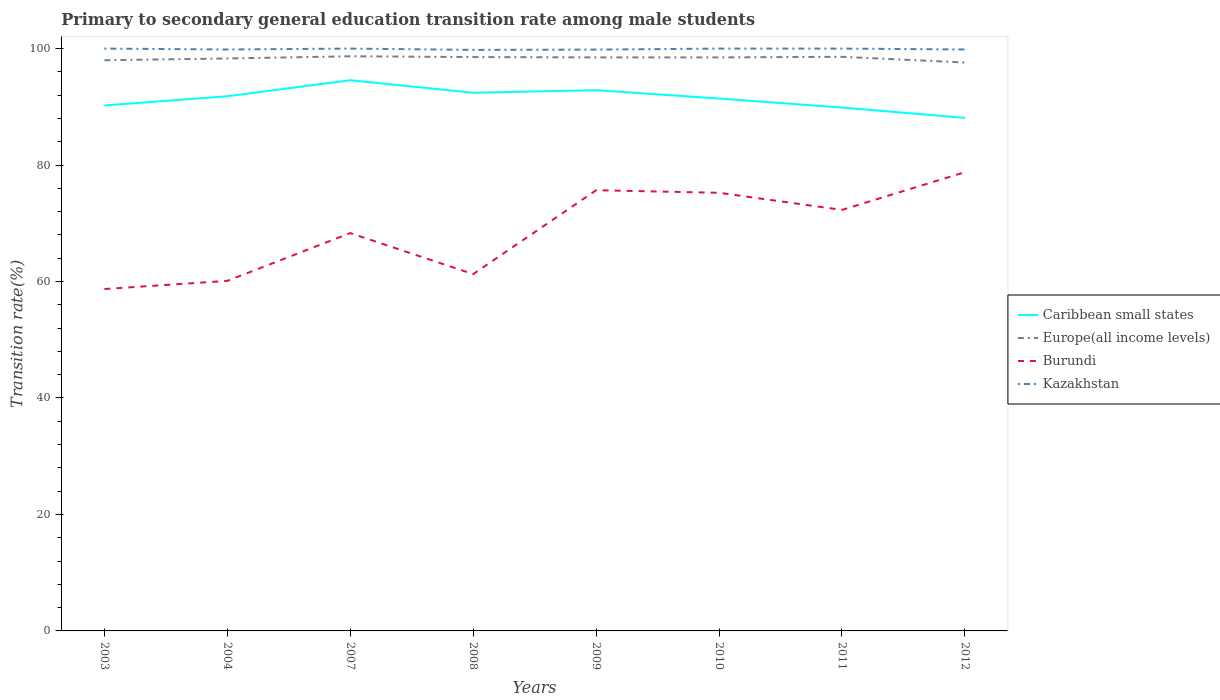Does the line corresponding to Europe(all income levels) intersect with the line corresponding to Burundi?
Your response must be concise. No. Is the number of lines equal to the number of legend labels?
Keep it short and to the point. Yes. Across all years, what is the maximum transition rate in Caribbean small states?
Keep it short and to the point. 88.11. In which year was the transition rate in Europe(all income levels) maximum?
Offer a terse response. 2012. What is the total transition rate in Kazakhstan in the graph?
Give a very brief answer. 0.15. What is the difference between the highest and the second highest transition rate in Caribbean small states?
Your answer should be very brief. 6.46. What is the difference between the highest and the lowest transition rate in Kazakhstan?
Your answer should be very brief. 4. How many years are there in the graph?
Offer a very short reply. 8. How many legend labels are there?
Offer a very short reply. 4. How are the legend labels stacked?
Your response must be concise. Vertical. What is the title of the graph?
Keep it short and to the point. Primary to secondary general education transition rate among male students. Does "Ethiopia" appear as one of the legend labels in the graph?
Give a very brief answer. No. What is the label or title of the X-axis?
Ensure brevity in your answer.  Years. What is the label or title of the Y-axis?
Offer a terse response. Transition rate(%). What is the Transition rate(%) in Caribbean small states in 2003?
Make the answer very short. 90.24. What is the Transition rate(%) in Europe(all income levels) in 2003?
Provide a succinct answer. 98. What is the Transition rate(%) of Burundi in 2003?
Give a very brief answer. 58.71. What is the Transition rate(%) of Caribbean small states in 2004?
Make the answer very short. 91.81. What is the Transition rate(%) in Europe(all income levels) in 2004?
Your response must be concise. 98.3. What is the Transition rate(%) in Burundi in 2004?
Ensure brevity in your answer.  60.12. What is the Transition rate(%) in Kazakhstan in 2004?
Offer a terse response. 99.84. What is the Transition rate(%) in Caribbean small states in 2007?
Give a very brief answer. 94.57. What is the Transition rate(%) of Europe(all income levels) in 2007?
Your answer should be very brief. 98.68. What is the Transition rate(%) in Burundi in 2007?
Make the answer very short. 68.32. What is the Transition rate(%) of Kazakhstan in 2007?
Give a very brief answer. 100. What is the Transition rate(%) of Caribbean small states in 2008?
Your response must be concise. 92.42. What is the Transition rate(%) of Europe(all income levels) in 2008?
Ensure brevity in your answer.  98.54. What is the Transition rate(%) in Burundi in 2008?
Your answer should be compact. 61.27. What is the Transition rate(%) of Kazakhstan in 2008?
Your answer should be very brief. 99.78. What is the Transition rate(%) in Caribbean small states in 2009?
Make the answer very short. 92.86. What is the Transition rate(%) of Europe(all income levels) in 2009?
Give a very brief answer. 98.49. What is the Transition rate(%) in Burundi in 2009?
Your response must be concise. 75.68. What is the Transition rate(%) of Kazakhstan in 2009?
Offer a very short reply. 99.83. What is the Transition rate(%) in Caribbean small states in 2010?
Your response must be concise. 91.42. What is the Transition rate(%) in Europe(all income levels) in 2010?
Give a very brief answer. 98.49. What is the Transition rate(%) in Burundi in 2010?
Your answer should be very brief. 75.24. What is the Transition rate(%) of Caribbean small states in 2011?
Ensure brevity in your answer.  89.88. What is the Transition rate(%) in Europe(all income levels) in 2011?
Your answer should be compact. 98.59. What is the Transition rate(%) in Burundi in 2011?
Your response must be concise. 72.3. What is the Transition rate(%) in Caribbean small states in 2012?
Offer a very short reply. 88.11. What is the Transition rate(%) of Europe(all income levels) in 2012?
Keep it short and to the point. 97.61. What is the Transition rate(%) in Burundi in 2012?
Provide a succinct answer. 78.78. What is the Transition rate(%) in Kazakhstan in 2012?
Offer a very short reply. 99.85. Across all years, what is the maximum Transition rate(%) of Caribbean small states?
Ensure brevity in your answer.  94.57. Across all years, what is the maximum Transition rate(%) of Europe(all income levels)?
Offer a very short reply. 98.68. Across all years, what is the maximum Transition rate(%) of Burundi?
Offer a very short reply. 78.78. Across all years, what is the maximum Transition rate(%) in Kazakhstan?
Provide a succinct answer. 100. Across all years, what is the minimum Transition rate(%) in Caribbean small states?
Ensure brevity in your answer.  88.11. Across all years, what is the minimum Transition rate(%) in Europe(all income levels)?
Your answer should be compact. 97.61. Across all years, what is the minimum Transition rate(%) of Burundi?
Your answer should be very brief. 58.71. Across all years, what is the minimum Transition rate(%) in Kazakhstan?
Offer a terse response. 99.78. What is the total Transition rate(%) of Caribbean small states in the graph?
Your response must be concise. 731.31. What is the total Transition rate(%) in Europe(all income levels) in the graph?
Your answer should be very brief. 786.71. What is the total Transition rate(%) of Burundi in the graph?
Your answer should be very brief. 550.42. What is the total Transition rate(%) of Kazakhstan in the graph?
Your answer should be very brief. 799.3. What is the difference between the Transition rate(%) of Caribbean small states in 2003 and that in 2004?
Your answer should be compact. -1.58. What is the difference between the Transition rate(%) of Europe(all income levels) in 2003 and that in 2004?
Ensure brevity in your answer.  -0.3. What is the difference between the Transition rate(%) of Burundi in 2003 and that in 2004?
Provide a short and direct response. -1.41. What is the difference between the Transition rate(%) in Kazakhstan in 2003 and that in 2004?
Ensure brevity in your answer.  0.16. What is the difference between the Transition rate(%) in Caribbean small states in 2003 and that in 2007?
Provide a short and direct response. -4.33. What is the difference between the Transition rate(%) of Europe(all income levels) in 2003 and that in 2007?
Keep it short and to the point. -0.68. What is the difference between the Transition rate(%) of Burundi in 2003 and that in 2007?
Your answer should be very brief. -9.61. What is the difference between the Transition rate(%) of Kazakhstan in 2003 and that in 2007?
Your answer should be very brief. 0. What is the difference between the Transition rate(%) of Caribbean small states in 2003 and that in 2008?
Keep it short and to the point. -2.18. What is the difference between the Transition rate(%) of Europe(all income levels) in 2003 and that in 2008?
Provide a short and direct response. -0.54. What is the difference between the Transition rate(%) of Burundi in 2003 and that in 2008?
Offer a very short reply. -2.56. What is the difference between the Transition rate(%) of Kazakhstan in 2003 and that in 2008?
Your answer should be compact. 0.22. What is the difference between the Transition rate(%) in Caribbean small states in 2003 and that in 2009?
Give a very brief answer. -2.62. What is the difference between the Transition rate(%) in Europe(all income levels) in 2003 and that in 2009?
Make the answer very short. -0.49. What is the difference between the Transition rate(%) of Burundi in 2003 and that in 2009?
Your answer should be compact. -16.97. What is the difference between the Transition rate(%) of Kazakhstan in 2003 and that in 2009?
Give a very brief answer. 0.17. What is the difference between the Transition rate(%) of Caribbean small states in 2003 and that in 2010?
Provide a succinct answer. -1.19. What is the difference between the Transition rate(%) of Europe(all income levels) in 2003 and that in 2010?
Make the answer very short. -0.48. What is the difference between the Transition rate(%) of Burundi in 2003 and that in 2010?
Make the answer very short. -16.52. What is the difference between the Transition rate(%) of Caribbean small states in 2003 and that in 2011?
Provide a short and direct response. 0.36. What is the difference between the Transition rate(%) in Europe(all income levels) in 2003 and that in 2011?
Provide a succinct answer. -0.58. What is the difference between the Transition rate(%) in Burundi in 2003 and that in 2011?
Your answer should be very brief. -13.59. What is the difference between the Transition rate(%) in Caribbean small states in 2003 and that in 2012?
Provide a succinct answer. 2.13. What is the difference between the Transition rate(%) of Europe(all income levels) in 2003 and that in 2012?
Offer a very short reply. 0.39. What is the difference between the Transition rate(%) of Burundi in 2003 and that in 2012?
Keep it short and to the point. -20.07. What is the difference between the Transition rate(%) of Kazakhstan in 2003 and that in 2012?
Provide a succinct answer. 0.15. What is the difference between the Transition rate(%) in Caribbean small states in 2004 and that in 2007?
Offer a terse response. -2.76. What is the difference between the Transition rate(%) of Europe(all income levels) in 2004 and that in 2007?
Your answer should be very brief. -0.38. What is the difference between the Transition rate(%) in Burundi in 2004 and that in 2007?
Keep it short and to the point. -8.2. What is the difference between the Transition rate(%) of Kazakhstan in 2004 and that in 2007?
Provide a succinct answer. -0.16. What is the difference between the Transition rate(%) in Caribbean small states in 2004 and that in 2008?
Give a very brief answer. -0.6. What is the difference between the Transition rate(%) of Europe(all income levels) in 2004 and that in 2008?
Provide a succinct answer. -0.24. What is the difference between the Transition rate(%) in Burundi in 2004 and that in 2008?
Make the answer very short. -1.16. What is the difference between the Transition rate(%) in Kazakhstan in 2004 and that in 2008?
Ensure brevity in your answer.  0.07. What is the difference between the Transition rate(%) in Caribbean small states in 2004 and that in 2009?
Provide a succinct answer. -1.05. What is the difference between the Transition rate(%) of Europe(all income levels) in 2004 and that in 2009?
Ensure brevity in your answer.  -0.19. What is the difference between the Transition rate(%) of Burundi in 2004 and that in 2009?
Provide a short and direct response. -15.57. What is the difference between the Transition rate(%) of Kazakhstan in 2004 and that in 2009?
Provide a short and direct response. 0.02. What is the difference between the Transition rate(%) of Caribbean small states in 2004 and that in 2010?
Your answer should be compact. 0.39. What is the difference between the Transition rate(%) of Europe(all income levels) in 2004 and that in 2010?
Provide a short and direct response. -0.18. What is the difference between the Transition rate(%) in Burundi in 2004 and that in 2010?
Ensure brevity in your answer.  -15.12. What is the difference between the Transition rate(%) of Kazakhstan in 2004 and that in 2010?
Your response must be concise. -0.16. What is the difference between the Transition rate(%) in Caribbean small states in 2004 and that in 2011?
Offer a terse response. 1.94. What is the difference between the Transition rate(%) of Europe(all income levels) in 2004 and that in 2011?
Provide a short and direct response. -0.28. What is the difference between the Transition rate(%) in Burundi in 2004 and that in 2011?
Make the answer very short. -12.18. What is the difference between the Transition rate(%) of Kazakhstan in 2004 and that in 2011?
Provide a succinct answer. -0.16. What is the difference between the Transition rate(%) of Caribbean small states in 2004 and that in 2012?
Keep it short and to the point. 3.7. What is the difference between the Transition rate(%) in Europe(all income levels) in 2004 and that in 2012?
Offer a very short reply. 0.69. What is the difference between the Transition rate(%) in Burundi in 2004 and that in 2012?
Your response must be concise. -18.66. What is the difference between the Transition rate(%) in Kazakhstan in 2004 and that in 2012?
Make the answer very short. -0. What is the difference between the Transition rate(%) in Caribbean small states in 2007 and that in 2008?
Give a very brief answer. 2.15. What is the difference between the Transition rate(%) of Europe(all income levels) in 2007 and that in 2008?
Your answer should be compact. 0.14. What is the difference between the Transition rate(%) in Burundi in 2007 and that in 2008?
Make the answer very short. 7.05. What is the difference between the Transition rate(%) in Kazakhstan in 2007 and that in 2008?
Ensure brevity in your answer.  0.22. What is the difference between the Transition rate(%) in Caribbean small states in 2007 and that in 2009?
Your answer should be very brief. 1.71. What is the difference between the Transition rate(%) in Europe(all income levels) in 2007 and that in 2009?
Ensure brevity in your answer.  0.19. What is the difference between the Transition rate(%) in Burundi in 2007 and that in 2009?
Your answer should be very brief. -7.36. What is the difference between the Transition rate(%) of Kazakhstan in 2007 and that in 2009?
Your answer should be compact. 0.17. What is the difference between the Transition rate(%) of Caribbean small states in 2007 and that in 2010?
Your answer should be very brief. 3.15. What is the difference between the Transition rate(%) in Europe(all income levels) in 2007 and that in 2010?
Provide a short and direct response. 0.19. What is the difference between the Transition rate(%) of Burundi in 2007 and that in 2010?
Your response must be concise. -6.92. What is the difference between the Transition rate(%) in Caribbean small states in 2007 and that in 2011?
Keep it short and to the point. 4.69. What is the difference between the Transition rate(%) in Europe(all income levels) in 2007 and that in 2011?
Ensure brevity in your answer.  0.09. What is the difference between the Transition rate(%) of Burundi in 2007 and that in 2011?
Your answer should be very brief. -3.98. What is the difference between the Transition rate(%) of Caribbean small states in 2007 and that in 2012?
Make the answer very short. 6.46. What is the difference between the Transition rate(%) in Europe(all income levels) in 2007 and that in 2012?
Your response must be concise. 1.07. What is the difference between the Transition rate(%) of Burundi in 2007 and that in 2012?
Your answer should be compact. -10.46. What is the difference between the Transition rate(%) in Kazakhstan in 2007 and that in 2012?
Provide a short and direct response. 0.15. What is the difference between the Transition rate(%) of Caribbean small states in 2008 and that in 2009?
Your answer should be compact. -0.44. What is the difference between the Transition rate(%) in Europe(all income levels) in 2008 and that in 2009?
Offer a terse response. 0.06. What is the difference between the Transition rate(%) in Burundi in 2008 and that in 2009?
Make the answer very short. -14.41. What is the difference between the Transition rate(%) in Kazakhstan in 2008 and that in 2009?
Your answer should be compact. -0.05. What is the difference between the Transition rate(%) in Caribbean small states in 2008 and that in 2010?
Make the answer very short. 0.99. What is the difference between the Transition rate(%) in Europe(all income levels) in 2008 and that in 2010?
Provide a succinct answer. 0.06. What is the difference between the Transition rate(%) of Burundi in 2008 and that in 2010?
Provide a short and direct response. -13.96. What is the difference between the Transition rate(%) in Kazakhstan in 2008 and that in 2010?
Make the answer very short. -0.22. What is the difference between the Transition rate(%) of Caribbean small states in 2008 and that in 2011?
Offer a very short reply. 2.54. What is the difference between the Transition rate(%) in Europe(all income levels) in 2008 and that in 2011?
Provide a succinct answer. -0.04. What is the difference between the Transition rate(%) in Burundi in 2008 and that in 2011?
Your answer should be very brief. -11.03. What is the difference between the Transition rate(%) in Kazakhstan in 2008 and that in 2011?
Provide a succinct answer. -0.22. What is the difference between the Transition rate(%) in Caribbean small states in 2008 and that in 2012?
Offer a terse response. 4.3. What is the difference between the Transition rate(%) in Europe(all income levels) in 2008 and that in 2012?
Offer a terse response. 0.93. What is the difference between the Transition rate(%) in Burundi in 2008 and that in 2012?
Make the answer very short. -17.51. What is the difference between the Transition rate(%) in Kazakhstan in 2008 and that in 2012?
Keep it short and to the point. -0.07. What is the difference between the Transition rate(%) in Caribbean small states in 2009 and that in 2010?
Provide a short and direct response. 1.44. What is the difference between the Transition rate(%) of Europe(all income levels) in 2009 and that in 2010?
Your answer should be compact. 0. What is the difference between the Transition rate(%) of Burundi in 2009 and that in 2010?
Keep it short and to the point. 0.45. What is the difference between the Transition rate(%) in Kazakhstan in 2009 and that in 2010?
Make the answer very short. -0.17. What is the difference between the Transition rate(%) of Caribbean small states in 2009 and that in 2011?
Make the answer very short. 2.98. What is the difference between the Transition rate(%) in Europe(all income levels) in 2009 and that in 2011?
Your answer should be compact. -0.1. What is the difference between the Transition rate(%) in Burundi in 2009 and that in 2011?
Your answer should be very brief. 3.38. What is the difference between the Transition rate(%) of Kazakhstan in 2009 and that in 2011?
Provide a short and direct response. -0.17. What is the difference between the Transition rate(%) of Caribbean small states in 2009 and that in 2012?
Provide a succinct answer. 4.75. What is the difference between the Transition rate(%) in Europe(all income levels) in 2009 and that in 2012?
Ensure brevity in your answer.  0.88. What is the difference between the Transition rate(%) in Burundi in 2009 and that in 2012?
Your response must be concise. -3.1. What is the difference between the Transition rate(%) of Kazakhstan in 2009 and that in 2012?
Your response must be concise. -0.02. What is the difference between the Transition rate(%) of Caribbean small states in 2010 and that in 2011?
Your response must be concise. 1.55. What is the difference between the Transition rate(%) of Europe(all income levels) in 2010 and that in 2011?
Your answer should be very brief. -0.1. What is the difference between the Transition rate(%) in Burundi in 2010 and that in 2011?
Give a very brief answer. 2.94. What is the difference between the Transition rate(%) in Caribbean small states in 2010 and that in 2012?
Your answer should be very brief. 3.31. What is the difference between the Transition rate(%) in Europe(all income levels) in 2010 and that in 2012?
Offer a terse response. 0.88. What is the difference between the Transition rate(%) in Burundi in 2010 and that in 2012?
Ensure brevity in your answer.  -3.54. What is the difference between the Transition rate(%) of Kazakhstan in 2010 and that in 2012?
Make the answer very short. 0.15. What is the difference between the Transition rate(%) in Caribbean small states in 2011 and that in 2012?
Offer a very short reply. 1.77. What is the difference between the Transition rate(%) in Europe(all income levels) in 2011 and that in 2012?
Provide a succinct answer. 0.98. What is the difference between the Transition rate(%) in Burundi in 2011 and that in 2012?
Your answer should be compact. -6.48. What is the difference between the Transition rate(%) of Kazakhstan in 2011 and that in 2012?
Make the answer very short. 0.15. What is the difference between the Transition rate(%) of Caribbean small states in 2003 and the Transition rate(%) of Europe(all income levels) in 2004?
Offer a terse response. -8.07. What is the difference between the Transition rate(%) of Caribbean small states in 2003 and the Transition rate(%) of Burundi in 2004?
Provide a succinct answer. 30.12. What is the difference between the Transition rate(%) in Caribbean small states in 2003 and the Transition rate(%) in Kazakhstan in 2004?
Provide a succinct answer. -9.61. What is the difference between the Transition rate(%) in Europe(all income levels) in 2003 and the Transition rate(%) in Burundi in 2004?
Keep it short and to the point. 37.89. What is the difference between the Transition rate(%) of Europe(all income levels) in 2003 and the Transition rate(%) of Kazakhstan in 2004?
Ensure brevity in your answer.  -1.84. What is the difference between the Transition rate(%) in Burundi in 2003 and the Transition rate(%) in Kazakhstan in 2004?
Provide a short and direct response. -41.13. What is the difference between the Transition rate(%) in Caribbean small states in 2003 and the Transition rate(%) in Europe(all income levels) in 2007?
Give a very brief answer. -8.45. What is the difference between the Transition rate(%) in Caribbean small states in 2003 and the Transition rate(%) in Burundi in 2007?
Provide a short and direct response. 21.92. What is the difference between the Transition rate(%) of Caribbean small states in 2003 and the Transition rate(%) of Kazakhstan in 2007?
Offer a very short reply. -9.76. What is the difference between the Transition rate(%) in Europe(all income levels) in 2003 and the Transition rate(%) in Burundi in 2007?
Your response must be concise. 29.68. What is the difference between the Transition rate(%) in Europe(all income levels) in 2003 and the Transition rate(%) in Kazakhstan in 2007?
Your answer should be compact. -2. What is the difference between the Transition rate(%) of Burundi in 2003 and the Transition rate(%) of Kazakhstan in 2007?
Keep it short and to the point. -41.29. What is the difference between the Transition rate(%) in Caribbean small states in 2003 and the Transition rate(%) in Europe(all income levels) in 2008?
Ensure brevity in your answer.  -8.31. What is the difference between the Transition rate(%) in Caribbean small states in 2003 and the Transition rate(%) in Burundi in 2008?
Provide a succinct answer. 28.96. What is the difference between the Transition rate(%) in Caribbean small states in 2003 and the Transition rate(%) in Kazakhstan in 2008?
Give a very brief answer. -9.54. What is the difference between the Transition rate(%) in Europe(all income levels) in 2003 and the Transition rate(%) in Burundi in 2008?
Your answer should be very brief. 36.73. What is the difference between the Transition rate(%) of Europe(all income levels) in 2003 and the Transition rate(%) of Kazakhstan in 2008?
Your answer should be very brief. -1.78. What is the difference between the Transition rate(%) in Burundi in 2003 and the Transition rate(%) in Kazakhstan in 2008?
Offer a terse response. -41.07. What is the difference between the Transition rate(%) of Caribbean small states in 2003 and the Transition rate(%) of Europe(all income levels) in 2009?
Offer a very short reply. -8.25. What is the difference between the Transition rate(%) of Caribbean small states in 2003 and the Transition rate(%) of Burundi in 2009?
Make the answer very short. 14.55. What is the difference between the Transition rate(%) of Caribbean small states in 2003 and the Transition rate(%) of Kazakhstan in 2009?
Your answer should be very brief. -9.59. What is the difference between the Transition rate(%) of Europe(all income levels) in 2003 and the Transition rate(%) of Burundi in 2009?
Your response must be concise. 22.32. What is the difference between the Transition rate(%) in Europe(all income levels) in 2003 and the Transition rate(%) in Kazakhstan in 2009?
Offer a very short reply. -1.82. What is the difference between the Transition rate(%) of Burundi in 2003 and the Transition rate(%) of Kazakhstan in 2009?
Keep it short and to the point. -41.12. What is the difference between the Transition rate(%) of Caribbean small states in 2003 and the Transition rate(%) of Europe(all income levels) in 2010?
Give a very brief answer. -8.25. What is the difference between the Transition rate(%) of Caribbean small states in 2003 and the Transition rate(%) of Burundi in 2010?
Your answer should be very brief. 15. What is the difference between the Transition rate(%) of Caribbean small states in 2003 and the Transition rate(%) of Kazakhstan in 2010?
Offer a very short reply. -9.76. What is the difference between the Transition rate(%) in Europe(all income levels) in 2003 and the Transition rate(%) in Burundi in 2010?
Provide a short and direct response. 22.77. What is the difference between the Transition rate(%) of Europe(all income levels) in 2003 and the Transition rate(%) of Kazakhstan in 2010?
Make the answer very short. -2. What is the difference between the Transition rate(%) of Burundi in 2003 and the Transition rate(%) of Kazakhstan in 2010?
Keep it short and to the point. -41.29. What is the difference between the Transition rate(%) in Caribbean small states in 2003 and the Transition rate(%) in Europe(all income levels) in 2011?
Give a very brief answer. -8.35. What is the difference between the Transition rate(%) of Caribbean small states in 2003 and the Transition rate(%) of Burundi in 2011?
Your answer should be very brief. 17.94. What is the difference between the Transition rate(%) in Caribbean small states in 2003 and the Transition rate(%) in Kazakhstan in 2011?
Make the answer very short. -9.76. What is the difference between the Transition rate(%) of Europe(all income levels) in 2003 and the Transition rate(%) of Burundi in 2011?
Give a very brief answer. 25.7. What is the difference between the Transition rate(%) in Europe(all income levels) in 2003 and the Transition rate(%) in Kazakhstan in 2011?
Your response must be concise. -2. What is the difference between the Transition rate(%) of Burundi in 2003 and the Transition rate(%) of Kazakhstan in 2011?
Your response must be concise. -41.29. What is the difference between the Transition rate(%) of Caribbean small states in 2003 and the Transition rate(%) of Europe(all income levels) in 2012?
Offer a terse response. -7.38. What is the difference between the Transition rate(%) of Caribbean small states in 2003 and the Transition rate(%) of Burundi in 2012?
Give a very brief answer. 11.46. What is the difference between the Transition rate(%) in Caribbean small states in 2003 and the Transition rate(%) in Kazakhstan in 2012?
Your answer should be very brief. -9.61. What is the difference between the Transition rate(%) in Europe(all income levels) in 2003 and the Transition rate(%) in Burundi in 2012?
Make the answer very short. 19.22. What is the difference between the Transition rate(%) in Europe(all income levels) in 2003 and the Transition rate(%) in Kazakhstan in 2012?
Keep it short and to the point. -1.84. What is the difference between the Transition rate(%) of Burundi in 2003 and the Transition rate(%) of Kazakhstan in 2012?
Your answer should be compact. -41.14. What is the difference between the Transition rate(%) of Caribbean small states in 2004 and the Transition rate(%) of Europe(all income levels) in 2007?
Offer a very short reply. -6.87. What is the difference between the Transition rate(%) of Caribbean small states in 2004 and the Transition rate(%) of Burundi in 2007?
Offer a very short reply. 23.49. What is the difference between the Transition rate(%) of Caribbean small states in 2004 and the Transition rate(%) of Kazakhstan in 2007?
Ensure brevity in your answer.  -8.19. What is the difference between the Transition rate(%) of Europe(all income levels) in 2004 and the Transition rate(%) of Burundi in 2007?
Your answer should be very brief. 29.98. What is the difference between the Transition rate(%) of Europe(all income levels) in 2004 and the Transition rate(%) of Kazakhstan in 2007?
Your answer should be very brief. -1.7. What is the difference between the Transition rate(%) of Burundi in 2004 and the Transition rate(%) of Kazakhstan in 2007?
Give a very brief answer. -39.88. What is the difference between the Transition rate(%) in Caribbean small states in 2004 and the Transition rate(%) in Europe(all income levels) in 2008?
Your response must be concise. -6.73. What is the difference between the Transition rate(%) of Caribbean small states in 2004 and the Transition rate(%) of Burundi in 2008?
Keep it short and to the point. 30.54. What is the difference between the Transition rate(%) in Caribbean small states in 2004 and the Transition rate(%) in Kazakhstan in 2008?
Your answer should be very brief. -7.97. What is the difference between the Transition rate(%) of Europe(all income levels) in 2004 and the Transition rate(%) of Burundi in 2008?
Offer a very short reply. 37.03. What is the difference between the Transition rate(%) of Europe(all income levels) in 2004 and the Transition rate(%) of Kazakhstan in 2008?
Provide a succinct answer. -1.48. What is the difference between the Transition rate(%) in Burundi in 2004 and the Transition rate(%) in Kazakhstan in 2008?
Your response must be concise. -39.66. What is the difference between the Transition rate(%) in Caribbean small states in 2004 and the Transition rate(%) in Europe(all income levels) in 2009?
Make the answer very short. -6.68. What is the difference between the Transition rate(%) of Caribbean small states in 2004 and the Transition rate(%) of Burundi in 2009?
Offer a terse response. 16.13. What is the difference between the Transition rate(%) in Caribbean small states in 2004 and the Transition rate(%) in Kazakhstan in 2009?
Offer a very short reply. -8.02. What is the difference between the Transition rate(%) in Europe(all income levels) in 2004 and the Transition rate(%) in Burundi in 2009?
Ensure brevity in your answer.  22.62. What is the difference between the Transition rate(%) of Europe(all income levels) in 2004 and the Transition rate(%) of Kazakhstan in 2009?
Ensure brevity in your answer.  -1.53. What is the difference between the Transition rate(%) of Burundi in 2004 and the Transition rate(%) of Kazakhstan in 2009?
Make the answer very short. -39.71. What is the difference between the Transition rate(%) of Caribbean small states in 2004 and the Transition rate(%) of Europe(all income levels) in 2010?
Provide a succinct answer. -6.67. What is the difference between the Transition rate(%) in Caribbean small states in 2004 and the Transition rate(%) in Burundi in 2010?
Your answer should be very brief. 16.58. What is the difference between the Transition rate(%) of Caribbean small states in 2004 and the Transition rate(%) of Kazakhstan in 2010?
Give a very brief answer. -8.19. What is the difference between the Transition rate(%) of Europe(all income levels) in 2004 and the Transition rate(%) of Burundi in 2010?
Your answer should be compact. 23.07. What is the difference between the Transition rate(%) in Europe(all income levels) in 2004 and the Transition rate(%) in Kazakhstan in 2010?
Your response must be concise. -1.7. What is the difference between the Transition rate(%) of Burundi in 2004 and the Transition rate(%) of Kazakhstan in 2010?
Offer a very short reply. -39.88. What is the difference between the Transition rate(%) of Caribbean small states in 2004 and the Transition rate(%) of Europe(all income levels) in 2011?
Offer a terse response. -6.77. What is the difference between the Transition rate(%) in Caribbean small states in 2004 and the Transition rate(%) in Burundi in 2011?
Your answer should be compact. 19.51. What is the difference between the Transition rate(%) in Caribbean small states in 2004 and the Transition rate(%) in Kazakhstan in 2011?
Provide a short and direct response. -8.19. What is the difference between the Transition rate(%) of Europe(all income levels) in 2004 and the Transition rate(%) of Burundi in 2011?
Your response must be concise. 26. What is the difference between the Transition rate(%) of Europe(all income levels) in 2004 and the Transition rate(%) of Kazakhstan in 2011?
Provide a short and direct response. -1.7. What is the difference between the Transition rate(%) of Burundi in 2004 and the Transition rate(%) of Kazakhstan in 2011?
Your answer should be very brief. -39.88. What is the difference between the Transition rate(%) in Caribbean small states in 2004 and the Transition rate(%) in Europe(all income levels) in 2012?
Provide a short and direct response. -5.8. What is the difference between the Transition rate(%) in Caribbean small states in 2004 and the Transition rate(%) in Burundi in 2012?
Your answer should be compact. 13.03. What is the difference between the Transition rate(%) in Caribbean small states in 2004 and the Transition rate(%) in Kazakhstan in 2012?
Keep it short and to the point. -8.03. What is the difference between the Transition rate(%) of Europe(all income levels) in 2004 and the Transition rate(%) of Burundi in 2012?
Keep it short and to the point. 19.52. What is the difference between the Transition rate(%) in Europe(all income levels) in 2004 and the Transition rate(%) in Kazakhstan in 2012?
Your response must be concise. -1.54. What is the difference between the Transition rate(%) in Burundi in 2004 and the Transition rate(%) in Kazakhstan in 2012?
Your answer should be very brief. -39.73. What is the difference between the Transition rate(%) of Caribbean small states in 2007 and the Transition rate(%) of Europe(all income levels) in 2008?
Your response must be concise. -3.97. What is the difference between the Transition rate(%) in Caribbean small states in 2007 and the Transition rate(%) in Burundi in 2008?
Make the answer very short. 33.3. What is the difference between the Transition rate(%) in Caribbean small states in 2007 and the Transition rate(%) in Kazakhstan in 2008?
Provide a short and direct response. -5.21. What is the difference between the Transition rate(%) of Europe(all income levels) in 2007 and the Transition rate(%) of Burundi in 2008?
Provide a succinct answer. 37.41. What is the difference between the Transition rate(%) of Europe(all income levels) in 2007 and the Transition rate(%) of Kazakhstan in 2008?
Ensure brevity in your answer.  -1.1. What is the difference between the Transition rate(%) of Burundi in 2007 and the Transition rate(%) of Kazakhstan in 2008?
Give a very brief answer. -31.46. What is the difference between the Transition rate(%) in Caribbean small states in 2007 and the Transition rate(%) in Europe(all income levels) in 2009?
Your response must be concise. -3.92. What is the difference between the Transition rate(%) in Caribbean small states in 2007 and the Transition rate(%) in Burundi in 2009?
Offer a very short reply. 18.89. What is the difference between the Transition rate(%) in Caribbean small states in 2007 and the Transition rate(%) in Kazakhstan in 2009?
Provide a short and direct response. -5.26. What is the difference between the Transition rate(%) of Europe(all income levels) in 2007 and the Transition rate(%) of Burundi in 2009?
Provide a succinct answer. 23. What is the difference between the Transition rate(%) in Europe(all income levels) in 2007 and the Transition rate(%) in Kazakhstan in 2009?
Ensure brevity in your answer.  -1.15. What is the difference between the Transition rate(%) in Burundi in 2007 and the Transition rate(%) in Kazakhstan in 2009?
Offer a very short reply. -31.51. What is the difference between the Transition rate(%) of Caribbean small states in 2007 and the Transition rate(%) of Europe(all income levels) in 2010?
Offer a terse response. -3.92. What is the difference between the Transition rate(%) in Caribbean small states in 2007 and the Transition rate(%) in Burundi in 2010?
Your answer should be compact. 19.33. What is the difference between the Transition rate(%) in Caribbean small states in 2007 and the Transition rate(%) in Kazakhstan in 2010?
Provide a succinct answer. -5.43. What is the difference between the Transition rate(%) in Europe(all income levels) in 2007 and the Transition rate(%) in Burundi in 2010?
Keep it short and to the point. 23.45. What is the difference between the Transition rate(%) in Europe(all income levels) in 2007 and the Transition rate(%) in Kazakhstan in 2010?
Your answer should be very brief. -1.32. What is the difference between the Transition rate(%) in Burundi in 2007 and the Transition rate(%) in Kazakhstan in 2010?
Provide a succinct answer. -31.68. What is the difference between the Transition rate(%) of Caribbean small states in 2007 and the Transition rate(%) of Europe(all income levels) in 2011?
Provide a succinct answer. -4.02. What is the difference between the Transition rate(%) in Caribbean small states in 2007 and the Transition rate(%) in Burundi in 2011?
Provide a short and direct response. 22.27. What is the difference between the Transition rate(%) of Caribbean small states in 2007 and the Transition rate(%) of Kazakhstan in 2011?
Make the answer very short. -5.43. What is the difference between the Transition rate(%) in Europe(all income levels) in 2007 and the Transition rate(%) in Burundi in 2011?
Provide a succinct answer. 26.38. What is the difference between the Transition rate(%) of Europe(all income levels) in 2007 and the Transition rate(%) of Kazakhstan in 2011?
Offer a terse response. -1.32. What is the difference between the Transition rate(%) in Burundi in 2007 and the Transition rate(%) in Kazakhstan in 2011?
Keep it short and to the point. -31.68. What is the difference between the Transition rate(%) in Caribbean small states in 2007 and the Transition rate(%) in Europe(all income levels) in 2012?
Ensure brevity in your answer.  -3.04. What is the difference between the Transition rate(%) in Caribbean small states in 2007 and the Transition rate(%) in Burundi in 2012?
Offer a very short reply. 15.79. What is the difference between the Transition rate(%) of Caribbean small states in 2007 and the Transition rate(%) of Kazakhstan in 2012?
Keep it short and to the point. -5.28. What is the difference between the Transition rate(%) in Europe(all income levels) in 2007 and the Transition rate(%) in Burundi in 2012?
Keep it short and to the point. 19.9. What is the difference between the Transition rate(%) of Europe(all income levels) in 2007 and the Transition rate(%) of Kazakhstan in 2012?
Provide a succinct answer. -1.16. What is the difference between the Transition rate(%) in Burundi in 2007 and the Transition rate(%) in Kazakhstan in 2012?
Your answer should be compact. -31.53. What is the difference between the Transition rate(%) of Caribbean small states in 2008 and the Transition rate(%) of Europe(all income levels) in 2009?
Your answer should be very brief. -6.07. What is the difference between the Transition rate(%) of Caribbean small states in 2008 and the Transition rate(%) of Burundi in 2009?
Your answer should be very brief. 16.73. What is the difference between the Transition rate(%) of Caribbean small states in 2008 and the Transition rate(%) of Kazakhstan in 2009?
Ensure brevity in your answer.  -7.41. What is the difference between the Transition rate(%) in Europe(all income levels) in 2008 and the Transition rate(%) in Burundi in 2009?
Give a very brief answer. 22.86. What is the difference between the Transition rate(%) in Europe(all income levels) in 2008 and the Transition rate(%) in Kazakhstan in 2009?
Ensure brevity in your answer.  -1.28. What is the difference between the Transition rate(%) in Burundi in 2008 and the Transition rate(%) in Kazakhstan in 2009?
Offer a very short reply. -38.55. What is the difference between the Transition rate(%) in Caribbean small states in 2008 and the Transition rate(%) in Europe(all income levels) in 2010?
Provide a succinct answer. -6.07. What is the difference between the Transition rate(%) of Caribbean small states in 2008 and the Transition rate(%) of Burundi in 2010?
Your response must be concise. 17.18. What is the difference between the Transition rate(%) in Caribbean small states in 2008 and the Transition rate(%) in Kazakhstan in 2010?
Ensure brevity in your answer.  -7.58. What is the difference between the Transition rate(%) of Europe(all income levels) in 2008 and the Transition rate(%) of Burundi in 2010?
Offer a very short reply. 23.31. What is the difference between the Transition rate(%) in Europe(all income levels) in 2008 and the Transition rate(%) in Kazakhstan in 2010?
Provide a succinct answer. -1.46. What is the difference between the Transition rate(%) of Burundi in 2008 and the Transition rate(%) of Kazakhstan in 2010?
Offer a very short reply. -38.73. What is the difference between the Transition rate(%) in Caribbean small states in 2008 and the Transition rate(%) in Europe(all income levels) in 2011?
Provide a short and direct response. -6.17. What is the difference between the Transition rate(%) of Caribbean small states in 2008 and the Transition rate(%) of Burundi in 2011?
Your response must be concise. 20.11. What is the difference between the Transition rate(%) of Caribbean small states in 2008 and the Transition rate(%) of Kazakhstan in 2011?
Offer a very short reply. -7.58. What is the difference between the Transition rate(%) in Europe(all income levels) in 2008 and the Transition rate(%) in Burundi in 2011?
Provide a short and direct response. 26.24. What is the difference between the Transition rate(%) of Europe(all income levels) in 2008 and the Transition rate(%) of Kazakhstan in 2011?
Keep it short and to the point. -1.46. What is the difference between the Transition rate(%) of Burundi in 2008 and the Transition rate(%) of Kazakhstan in 2011?
Provide a succinct answer. -38.73. What is the difference between the Transition rate(%) in Caribbean small states in 2008 and the Transition rate(%) in Europe(all income levels) in 2012?
Provide a succinct answer. -5.2. What is the difference between the Transition rate(%) of Caribbean small states in 2008 and the Transition rate(%) of Burundi in 2012?
Offer a terse response. 13.64. What is the difference between the Transition rate(%) of Caribbean small states in 2008 and the Transition rate(%) of Kazakhstan in 2012?
Give a very brief answer. -7.43. What is the difference between the Transition rate(%) of Europe(all income levels) in 2008 and the Transition rate(%) of Burundi in 2012?
Ensure brevity in your answer.  19.77. What is the difference between the Transition rate(%) of Europe(all income levels) in 2008 and the Transition rate(%) of Kazakhstan in 2012?
Give a very brief answer. -1.3. What is the difference between the Transition rate(%) of Burundi in 2008 and the Transition rate(%) of Kazakhstan in 2012?
Your response must be concise. -38.57. What is the difference between the Transition rate(%) in Caribbean small states in 2009 and the Transition rate(%) in Europe(all income levels) in 2010?
Make the answer very short. -5.63. What is the difference between the Transition rate(%) of Caribbean small states in 2009 and the Transition rate(%) of Burundi in 2010?
Offer a very short reply. 17.62. What is the difference between the Transition rate(%) in Caribbean small states in 2009 and the Transition rate(%) in Kazakhstan in 2010?
Give a very brief answer. -7.14. What is the difference between the Transition rate(%) in Europe(all income levels) in 2009 and the Transition rate(%) in Burundi in 2010?
Provide a short and direct response. 23.25. What is the difference between the Transition rate(%) in Europe(all income levels) in 2009 and the Transition rate(%) in Kazakhstan in 2010?
Offer a very short reply. -1.51. What is the difference between the Transition rate(%) of Burundi in 2009 and the Transition rate(%) of Kazakhstan in 2010?
Give a very brief answer. -24.32. What is the difference between the Transition rate(%) of Caribbean small states in 2009 and the Transition rate(%) of Europe(all income levels) in 2011?
Your answer should be compact. -5.73. What is the difference between the Transition rate(%) of Caribbean small states in 2009 and the Transition rate(%) of Burundi in 2011?
Ensure brevity in your answer.  20.56. What is the difference between the Transition rate(%) in Caribbean small states in 2009 and the Transition rate(%) in Kazakhstan in 2011?
Your answer should be very brief. -7.14. What is the difference between the Transition rate(%) in Europe(all income levels) in 2009 and the Transition rate(%) in Burundi in 2011?
Offer a terse response. 26.19. What is the difference between the Transition rate(%) in Europe(all income levels) in 2009 and the Transition rate(%) in Kazakhstan in 2011?
Your answer should be very brief. -1.51. What is the difference between the Transition rate(%) in Burundi in 2009 and the Transition rate(%) in Kazakhstan in 2011?
Provide a short and direct response. -24.32. What is the difference between the Transition rate(%) in Caribbean small states in 2009 and the Transition rate(%) in Europe(all income levels) in 2012?
Offer a terse response. -4.75. What is the difference between the Transition rate(%) of Caribbean small states in 2009 and the Transition rate(%) of Burundi in 2012?
Make the answer very short. 14.08. What is the difference between the Transition rate(%) in Caribbean small states in 2009 and the Transition rate(%) in Kazakhstan in 2012?
Provide a short and direct response. -6.99. What is the difference between the Transition rate(%) in Europe(all income levels) in 2009 and the Transition rate(%) in Burundi in 2012?
Provide a succinct answer. 19.71. What is the difference between the Transition rate(%) in Europe(all income levels) in 2009 and the Transition rate(%) in Kazakhstan in 2012?
Ensure brevity in your answer.  -1.36. What is the difference between the Transition rate(%) of Burundi in 2009 and the Transition rate(%) of Kazakhstan in 2012?
Your answer should be compact. -24.17. What is the difference between the Transition rate(%) of Caribbean small states in 2010 and the Transition rate(%) of Europe(all income levels) in 2011?
Keep it short and to the point. -7.16. What is the difference between the Transition rate(%) of Caribbean small states in 2010 and the Transition rate(%) of Burundi in 2011?
Offer a terse response. 19.12. What is the difference between the Transition rate(%) of Caribbean small states in 2010 and the Transition rate(%) of Kazakhstan in 2011?
Your response must be concise. -8.58. What is the difference between the Transition rate(%) of Europe(all income levels) in 2010 and the Transition rate(%) of Burundi in 2011?
Your answer should be compact. 26.19. What is the difference between the Transition rate(%) of Europe(all income levels) in 2010 and the Transition rate(%) of Kazakhstan in 2011?
Offer a terse response. -1.51. What is the difference between the Transition rate(%) in Burundi in 2010 and the Transition rate(%) in Kazakhstan in 2011?
Your answer should be compact. -24.76. What is the difference between the Transition rate(%) in Caribbean small states in 2010 and the Transition rate(%) in Europe(all income levels) in 2012?
Provide a succinct answer. -6.19. What is the difference between the Transition rate(%) of Caribbean small states in 2010 and the Transition rate(%) of Burundi in 2012?
Your response must be concise. 12.64. What is the difference between the Transition rate(%) in Caribbean small states in 2010 and the Transition rate(%) in Kazakhstan in 2012?
Provide a succinct answer. -8.42. What is the difference between the Transition rate(%) of Europe(all income levels) in 2010 and the Transition rate(%) of Burundi in 2012?
Make the answer very short. 19.71. What is the difference between the Transition rate(%) of Europe(all income levels) in 2010 and the Transition rate(%) of Kazakhstan in 2012?
Your answer should be very brief. -1.36. What is the difference between the Transition rate(%) in Burundi in 2010 and the Transition rate(%) in Kazakhstan in 2012?
Your response must be concise. -24.61. What is the difference between the Transition rate(%) of Caribbean small states in 2011 and the Transition rate(%) of Europe(all income levels) in 2012?
Offer a terse response. -7.73. What is the difference between the Transition rate(%) of Caribbean small states in 2011 and the Transition rate(%) of Burundi in 2012?
Your answer should be very brief. 11.1. What is the difference between the Transition rate(%) of Caribbean small states in 2011 and the Transition rate(%) of Kazakhstan in 2012?
Keep it short and to the point. -9.97. What is the difference between the Transition rate(%) in Europe(all income levels) in 2011 and the Transition rate(%) in Burundi in 2012?
Make the answer very short. 19.81. What is the difference between the Transition rate(%) of Europe(all income levels) in 2011 and the Transition rate(%) of Kazakhstan in 2012?
Your answer should be compact. -1.26. What is the difference between the Transition rate(%) in Burundi in 2011 and the Transition rate(%) in Kazakhstan in 2012?
Offer a terse response. -27.55. What is the average Transition rate(%) in Caribbean small states per year?
Provide a short and direct response. 91.41. What is the average Transition rate(%) in Europe(all income levels) per year?
Offer a very short reply. 98.34. What is the average Transition rate(%) of Burundi per year?
Your response must be concise. 68.8. What is the average Transition rate(%) in Kazakhstan per year?
Provide a short and direct response. 99.91. In the year 2003, what is the difference between the Transition rate(%) in Caribbean small states and Transition rate(%) in Europe(all income levels)?
Keep it short and to the point. -7.77. In the year 2003, what is the difference between the Transition rate(%) of Caribbean small states and Transition rate(%) of Burundi?
Your answer should be compact. 31.52. In the year 2003, what is the difference between the Transition rate(%) of Caribbean small states and Transition rate(%) of Kazakhstan?
Give a very brief answer. -9.76. In the year 2003, what is the difference between the Transition rate(%) of Europe(all income levels) and Transition rate(%) of Burundi?
Offer a very short reply. 39.29. In the year 2003, what is the difference between the Transition rate(%) in Europe(all income levels) and Transition rate(%) in Kazakhstan?
Your answer should be very brief. -2. In the year 2003, what is the difference between the Transition rate(%) of Burundi and Transition rate(%) of Kazakhstan?
Provide a short and direct response. -41.29. In the year 2004, what is the difference between the Transition rate(%) of Caribbean small states and Transition rate(%) of Europe(all income levels)?
Offer a terse response. -6.49. In the year 2004, what is the difference between the Transition rate(%) in Caribbean small states and Transition rate(%) in Burundi?
Your answer should be very brief. 31.7. In the year 2004, what is the difference between the Transition rate(%) in Caribbean small states and Transition rate(%) in Kazakhstan?
Offer a terse response. -8.03. In the year 2004, what is the difference between the Transition rate(%) in Europe(all income levels) and Transition rate(%) in Burundi?
Your answer should be compact. 38.19. In the year 2004, what is the difference between the Transition rate(%) in Europe(all income levels) and Transition rate(%) in Kazakhstan?
Ensure brevity in your answer.  -1.54. In the year 2004, what is the difference between the Transition rate(%) of Burundi and Transition rate(%) of Kazakhstan?
Your answer should be compact. -39.73. In the year 2007, what is the difference between the Transition rate(%) of Caribbean small states and Transition rate(%) of Europe(all income levels)?
Your response must be concise. -4.11. In the year 2007, what is the difference between the Transition rate(%) in Caribbean small states and Transition rate(%) in Burundi?
Give a very brief answer. 26.25. In the year 2007, what is the difference between the Transition rate(%) of Caribbean small states and Transition rate(%) of Kazakhstan?
Provide a short and direct response. -5.43. In the year 2007, what is the difference between the Transition rate(%) of Europe(all income levels) and Transition rate(%) of Burundi?
Give a very brief answer. 30.36. In the year 2007, what is the difference between the Transition rate(%) in Europe(all income levels) and Transition rate(%) in Kazakhstan?
Give a very brief answer. -1.32. In the year 2007, what is the difference between the Transition rate(%) of Burundi and Transition rate(%) of Kazakhstan?
Provide a succinct answer. -31.68. In the year 2008, what is the difference between the Transition rate(%) in Caribbean small states and Transition rate(%) in Europe(all income levels)?
Provide a succinct answer. -6.13. In the year 2008, what is the difference between the Transition rate(%) in Caribbean small states and Transition rate(%) in Burundi?
Offer a very short reply. 31.14. In the year 2008, what is the difference between the Transition rate(%) in Caribbean small states and Transition rate(%) in Kazakhstan?
Your response must be concise. -7.36. In the year 2008, what is the difference between the Transition rate(%) in Europe(all income levels) and Transition rate(%) in Burundi?
Ensure brevity in your answer.  37.27. In the year 2008, what is the difference between the Transition rate(%) of Europe(all income levels) and Transition rate(%) of Kazakhstan?
Provide a succinct answer. -1.24. In the year 2008, what is the difference between the Transition rate(%) of Burundi and Transition rate(%) of Kazakhstan?
Provide a succinct answer. -38.51. In the year 2009, what is the difference between the Transition rate(%) of Caribbean small states and Transition rate(%) of Europe(all income levels)?
Your response must be concise. -5.63. In the year 2009, what is the difference between the Transition rate(%) of Caribbean small states and Transition rate(%) of Burundi?
Offer a terse response. 17.18. In the year 2009, what is the difference between the Transition rate(%) of Caribbean small states and Transition rate(%) of Kazakhstan?
Provide a succinct answer. -6.97. In the year 2009, what is the difference between the Transition rate(%) of Europe(all income levels) and Transition rate(%) of Burundi?
Provide a short and direct response. 22.81. In the year 2009, what is the difference between the Transition rate(%) in Europe(all income levels) and Transition rate(%) in Kazakhstan?
Make the answer very short. -1.34. In the year 2009, what is the difference between the Transition rate(%) in Burundi and Transition rate(%) in Kazakhstan?
Your answer should be compact. -24.15. In the year 2010, what is the difference between the Transition rate(%) in Caribbean small states and Transition rate(%) in Europe(all income levels)?
Offer a very short reply. -7.06. In the year 2010, what is the difference between the Transition rate(%) in Caribbean small states and Transition rate(%) in Burundi?
Your response must be concise. 16.19. In the year 2010, what is the difference between the Transition rate(%) in Caribbean small states and Transition rate(%) in Kazakhstan?
Provide a succinct answer. -8.58. In the year 2010, what is the difference between the Transition rate(%) of Europe(all income levels) and Transition rate(%) of Burundi?
Give a very brief answer. 23.25. In the year 2010, what is the difference between the Transition rate(%) of Europe(all income levels) and Transition rate(%) of Kazakhstan?
Provide a succinct answer. -1.51. In the year 2010, what is the difference between the Transition rate(%) of Burundi and Transition rate(%) of Kazakhstan?
Your answer should be compact. -24.76. In the year 2011, what is the difference between the Transition rate(%) in Caribbean small states and Transition rate(%) in Europe(all income levels)?
Give a very brief answer. -8.71. In the year 2011, what is the difference between the Transition rate(%) in Caribbean small states and Transition rate(%) in Burundi?
Your response must be concise. 17.58. In the year 2011, what is the difference between the Transition rate(%) of Caribbean small states and Transition rate(%) of Kazakhstan?
Offer a very short reply. -10.12. In the year 2011, what is the difference between the Transition rate(%) of Europe(all income levels) and Transition rate(%) of Burundi?
Offer a very short reply. 26.29. In the year 2011, what is the difference between the Transition rate(%) in Europe(all income levels) and Transition rate(%) in Kazakhstan?
Provide a short and direct response. -1.41. In the year 2011, what is the difference between the Transition rate(%) of Burundi and Transition rate(%) of Kazakhstan?
Ensure brevity in your answer.  -27.7. In the year 2012, what is the difference between the Transition rate(%) in Caribbean small states and Transition rate(%) in Europe(all income levels)?
Your answer should be compact. -9.5. In the year 2012, what is the difference between the Transition rate(%) in Caribbean small states and Transition rate(%) in Burundi?
Your answer should be very brief. 9.33. In the year 2012, what is the difference between the Transition rate(%) of Caribbean small states and Transition rate(%) of Kazakhstan?
Keep it short and to the point. -11.74. In the year 2012, what is the difference between the Transition rate(%) in Europe(all income levels) and Transition rate(%) in Burundi?
Your answer should be very brief. 18.83. In the year 2012, what is the difference between the Transition rate(%) of Europe(all income levels) and Transition rate(%) of Kazakhstan?
Your answer should be compact. -2.24. In the year 2012, what is the difference between the Transition rate(%) in Burundi and Transition rate(%) in Kazakhstan?
Your answer should be very brief. -21.07. What is the ratio of the Transition rate(%) of Caribbean small states in 2003 to that in 2004?
Give a very brief answer. 0.98. What is the ratio of the Transition rate(%) of Burundi in 2003 to that in 2004?
Your answer should be very brief. 0.98. What is the ratio of the Transition rate(%) in Kazakhstan in 2003 to that in 2004?
Offer a terse response. 1. What is the ratio of the Transition rate(%) in Caribbean small states in 2003 to that in 2007?
Provide a short and direct response. 0.95. What is the ratio of the Transition rate(%) of Burundi in 2003 to that in 2007?
Provide a short and direct response. 0.86. What is the ratio of the Transition rate(%) of Caribbean small states in 2003 to that in 2008?
Offer a very short reply. 0.98. What is the ratio of the Transition rate(%) of Burundi in 2003 to that in 2008?
Keep it short and to the point. 0.96. What is the ratio of the Transition rate(%) of Kazakhstan in 2003 to that in 2008?
Keep it short and to the point. 1. What is the ratio of the Transition rate(%) of Caribbean small states in 2003 to that in 2009?
Offer a very short reply. 0.97. What is the ratio of the Transition rate(%) of Burundi in 2003 to that in 2009?
Give a very brief answer. 0.78. What is the ratio of the Transition rate(%) of Kazakhstan in 2003 to that in 2009?
Keep it short and to the point. 1. What is the ratio of the Transition rate(%) in Caribbean small states in 2003 to that in 2010?
Your answer should be compact. 0.99. What is the ratio of the Transition rate(%) in Burundi in 2003 to that in 2010?
Give a very brief answer. 0.78. What is the ratio of the Transition rate(%) in Kazakhstan in 2003 to that in 2010?
Keep it short and to the point. 1. What is the ratio of the Transition rate(%) of Caribbean small states in 2003 to that in 2011?
Keep it short and to the point. 1. What is the ratio of the Transition rate(%) of Europe(all income levels) in 2003 to that in 2011?
Offer a very short reply. 0.99. What is the ratio of the Transition rate(%) in Burundi in 2003 to that in 2011?
Provide a succinct answer. 0.81. What is the ratio of the Transition rate(%) of Kazakhstan in 2003 to that in 2011?
Make the answer very short. 1. What is the ratio of the Transition rate(%) in Caribbean small states in 2003 to that in 2012?
Ensure brevity in your answer.  1.02. What is the ratio of the Transition rate(%) of Burundi in 2003 to that in 2012?
Your response must be concise. 0.75. What is the ratio of the Transition rate(%) of Caribbean small states in 2004 to that in 2007?
Your answer should be compact. 0.97. What is the ratio of the Transition rate(%) of Burundi in 2004 to that in 2007?
Give a very brief answer. 0.88. What is the ratio of the Transition rate(%) in Kazakhstan in 2004 to that in 2007?
Keep it short and to the point. 1. What is the ratio of the Transition rate(%) in Caribbean small states in 2004 to that in 2008?
Make the answer very short. 0.99. What is the ratio of the Transition rate(%) in Europe(all income levels) in 2004 to that in 2008?
Offer a very short reply. 1. What is the ratio of the Transition rate(%) of Burundi in 2004 to that in 2008?
Give a very brief answer. 0.98. What is the ratio of the Transition rate(%) in Kazakhstan in 2004 to that in 2008?
Give a very brief answer. 1. What is the ratio of the Transition rate(%) of Caribbean small states in 2004 to that in 2009?
Ensure brevity in your answer.  0.99. What is the ratio of the Transition rate(%) in Europe(all income levels) in 2004 to that in 2009?
Give a very brief answer. 1. What is the ratio of the Transition rate(%) of Burundi in 2004 to that in 2009?
Make the answer very short. 0.79. What is the ratio of the Transition rate(%) in Caribbean small states in 2004 to that in 2010?
Make the answer very short. 1. What is the ratio of the Transition rate(%) of Burundi in 2004 to that in 2010?
Keep it short and to the point. 0.8. What is the ratio of the Transition rate(%) of Caribbean small states in 2004 to that in 2011?
Ensure brevity in your answer.  1.02. What is the ratio of the Transition rate(%) of Burundi in 2004 to that in 2011?
Provide a succinct answer. 0.83. What is the ratio of the Transition rate(%) in Caribbean small states in 2004 to that in 2012?
Provide a short and direct response. 1.04. What is the ratio of the Transition rate(%) of Europe(all income levels) in 2004 to that in 2012?
Ensure brevity in your answer.  1.01. What is the ratio of the Transition rate(%) in Burundi in 2004 to that in 2012?
Keep it short and to the point. 0.76. What is the ratio of the Transition rate(%) of Kazakhstan in 2004 to that in 2012?
Keep it short and to the point. 1. What is the ratio of the Transition rate(%) of Caribbean small states in 2007 to that in 2008?
Your answer should be very brief. 1.02. What is the ratio of the Transition rate(%) in Burundi in 2007 to that in 2008?
Provide a succinct answer. 1.11. What is the ratio of the Transition rate(%) of Kazakhstan in 2007 to that in 2008?
Keep it short and to the point. 1. What is the ratio of the Transition rate(%) of Caribbean small states in 2007 to that in 2009?
Your answer should be compact. 1.02. What is the ratio of the Transition rate(%) of Europe(all income levels) in 2007 to that in 2009?
Your answer should be very brief. 1. What is the ratio of the Transition rate(%) in Burundi in 2007 to that in 2009?
Provide a short and direct response. 0.9. What is the ratio of the Transition rate(%) of Kazakhstan in 2007 to that in 2009?
Give a very brief answer. 1. What is the ratio of the Transition rate(%) in Caribbean small states in 2007 to that in 2010?
Ensure brevity in your answer.  1.03. What is the ratio of the Transition rate(%) of Burundi in 2007 to that in 2010?
Provide a succinct answer. 0.91. What is the ratio of the Transition rate(%) in Caribbean small states in 2007 to that in 2011?
Your answer should be compact. 1.05. What is the ratio of the Transition rate(%) in Burundi in 2007 to that in 2011?
Your answer should be very brief. 0.94. What is the ratio of the Transition rate(%) of Kazakhstan in 2007 to that in 2011?
Make the answer very short. 1. What is the ratio of the Transition rate(%) of Caribbean small states in 2007 to that in 2012?
Your answer should be very brief. 1.07. What is the ratio of the Transition rate(%) of Europe(all income levels) in 2007 to that in 2012?
Keep it short and to the point. 1.01. What is the ratio of the Transition rate(%) of Burundi in 2007 to that in 2012?
Ensure brevity in your answer.  0.87. What is the ratio of the Transition rate(%) of Caribbean small states in 2008 to that in 2009?
Make the answer very short. 1. What is the ratio of the Transition rate(%) of Europe(all income levels) in 2008 to that in 2009?
Offer a very short reply. 1. What is the ratio of the Transition rate(%) of Burundi in 2008 to that in 2009?
Keep it short and to the point. 0.81. What is the ratio of the Transition rate(%) of Kazakhstan in 2008 to that in 2009?
Make the answer very short. 1. What is the ratio of the Transition rate(%) of Caribbean small states in 2008 to that in 2010?
Ensure brevity in your answer.  1.01. What is the ratio of the Transition rate(%) of Europe(all income levels) in 2008 to that in 2010?
Make the answer very short. 1. What is the ratio of the Transition rate(%) of Burundi in 2008 to that in 2010?
Offer a very short reply. 0.81. What is the ratio of the Transition rate(%) of Caribbean small states in 2008 to that in 2011?
Your response must be concise. 1.03. What is the ratio of the Transition rate(%) in Europe(all income levels) in 2008 to that in 2011?
Your answer should be very brief. 1. What is the ratio of the Transition rate(%) of Burundi in 2008 to that in 2011?
Your response must be concise. 0.85. What is the ratio of the Transition rate(%) in Caribbean small states in 2008 to that in 2012?
Ensure brevity in your answer.  1.05. What is the ratio of the Transition rate(%) in Europe(all income levels) in 2008 to that in 2012?
Ensure brevity in your answer.  1.01. What is the ratio of the Transition rate(%) in Burundi in 2008 to that in 2012?
Your answer should be compact. 0.78. What is the ratio of the Transition rate(%) in Kazakhstan in 2008 to that in 2012?
Your answer should be compact. 1. What is the ratio of the Transition rate(%) of Caribbean small states in 2009 to that in 2010?
Provide a succinct answer. 1.02. What is the ratio of the Transition rate(%) in Burundi in 2009 to that in 2010?
Provide a succinct answer. 1.01. What is the ratio of the Transition rate(%) in Kazakhstan in 2009 to that in 2010?
Your answer should be very brief. 1. What is the ratio of the Transition rate(%) in Caribbean small states in 2009 to that in 2011?
Provide a succinct answer. 1.03. What is the ratio of the Transition rate(%) in Europe(all income levels) in 2009 to that in 2011?
Provide a short and direct response. 1. What is the ratio of the Transition rate(%) in Burundi in 2009 to that in 2011?
Offer a terse response. 1.05. What is the ratio of the Transition rate(%) in Kazakhstan in 2009 to that in 2011?
Make the answer very short. 1. What is the ratio of the Transition rate(%) in Caribbean small states in 2009 to that in 2012?
Provide a succinct answer. 1.05. What is the ratio of the Transition rate(%) in Burundi in 2009 to that in 2012?
Give a very brief answer. 0.96. What is the ratio of the Transition rate(%) of Caribbean small states in 2010 to that in 2011?
Offer a terse response. 1.02. What is the ratio of the Transition rate(%) in Burundi in 2010 to that in 2011?
Keep it short and to the point. 1.04. What is the ratio of the Transition rate(%) in Caribbean small states in 2010 to that in 2012?
Give a very brief answer. 1.04. What is the ratio of the Transition rate(%) in Europe(all income levels) in 2010 to that in 2012?
Your answer should be very brief. 1.01. What is the ratio of the Transition rate(%) of Burundi in 2010 to that in 2012?
Your answer should be very brief. 0.95. What is the ratio of the Transition rate(%) of Kazakhstan in 2010 to that in 2012?
Your answer should be very brief. 1. What is the ratio of the Transition rate(%) of Burundi in 2011 to that in 2012?
Offer a very short reply. 0.92. What is the ratio of the Transition rate(%) of Kazakhstan in 2011 to that in 2012?
Give a very brief answer. 1. What is the difference between the highest and the second highest Transition rate(%) of Caribbean small states?
Your answer should be compact. 1.71. What is the difference between the highest and the second highest Transition rate(%) of Europe(all income levels)?
Your answer should be very brief. 0.09. What is the difference between the highest and the second highest Transition rate(%) in Burundi?
Give a very brief answer. 3.1. What is the difference between the highest and the second highest Transition rate(%) of Kazakhstan?
Make the answer very short. 0. What is the difference between the highest and the lowest Transition rate(%) in Caribbean small states?
Make the answer very short. 6.46. What is the difference between the highest and the lowest Transition rate(%) in Europe(all income levels)?
Give a very brief answer. 1.07. What is the difference between the highest and the lowest Transition rate(%) of Burundi?
Provide a succinct answer. 20.07. What is the difference between the highest and the lowest Transition rate(%) in Kazakhstan?
Provide a short and direct response. 0.22. 